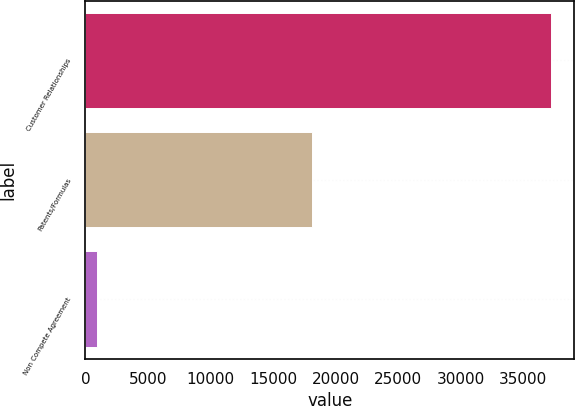Convert chart to OTSL. <chart><loc_0><loc_0><loc_500><loc_500><bar_chart><fcel>Customer Relationships<fcel>Patents/Formulas<fcel>Non Compete Agreement<nl><fcel>37205<fcel>18084<fcel>918<nl></chart> 